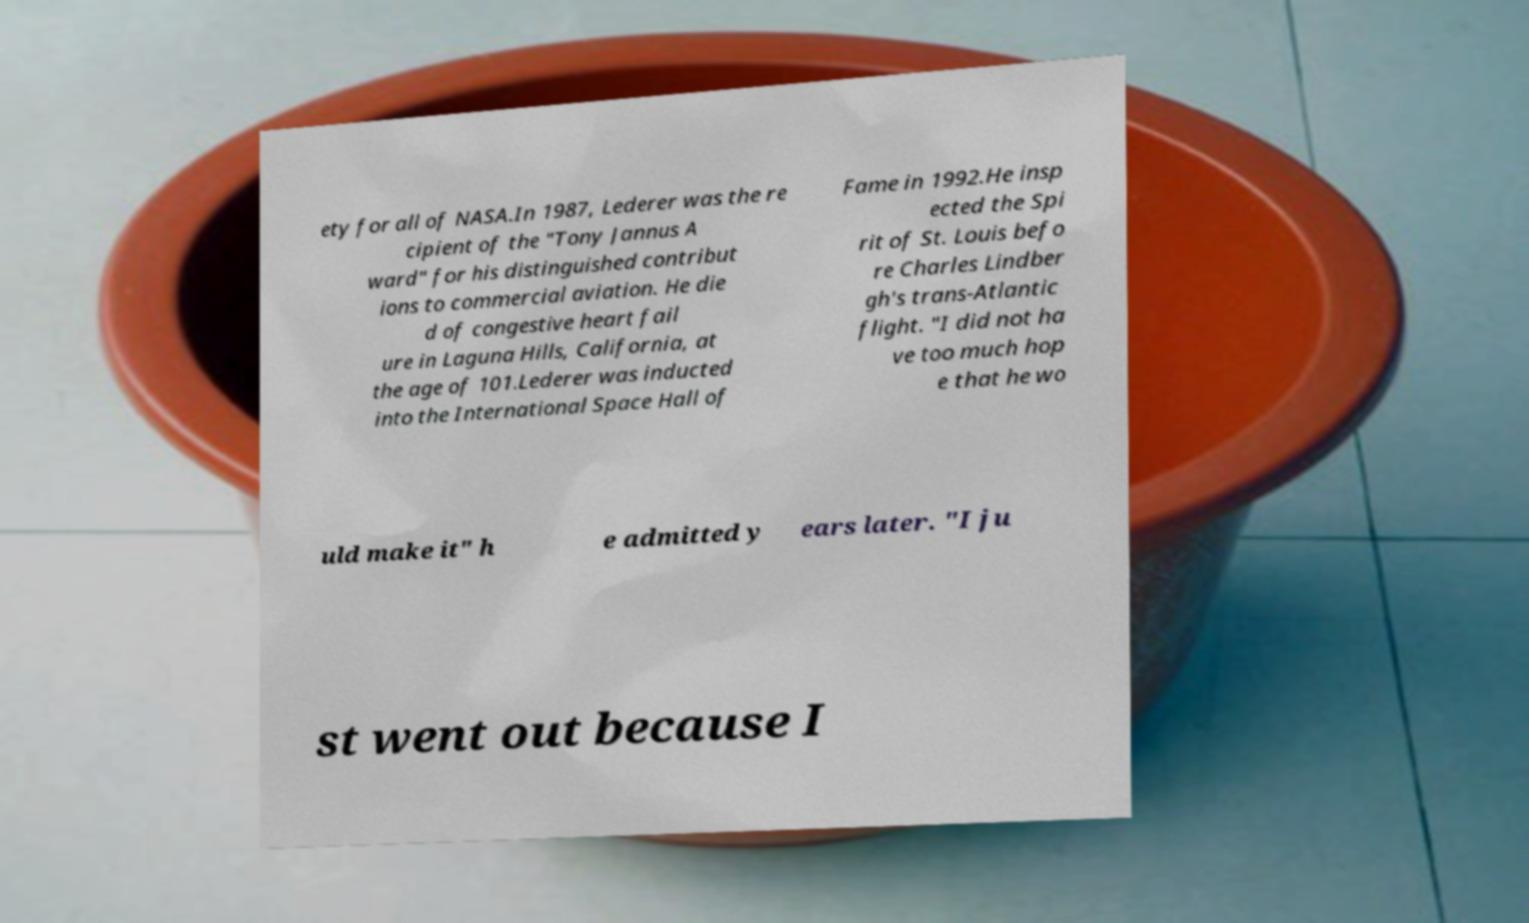Please identify and transcribe the text found in this image. ety for all of NASA.In 1987, Lederer was the re cipient of the "Tony Jannus A ward" for his distinguished contribut ions to commercial aviation. He die d of congestive heart fail ure in Laguna Hills, California, at the age of 101.Lederer was inducted into the International Space Hall of Fame in 1992.He insp ected the Spi rit of St. Louis befo re Charles Lindber gh's trans-Atlantic flight. "I did not ha ve too much hop e that he wo uld make it" h e admitted y ears later. "I ju st went out because I 